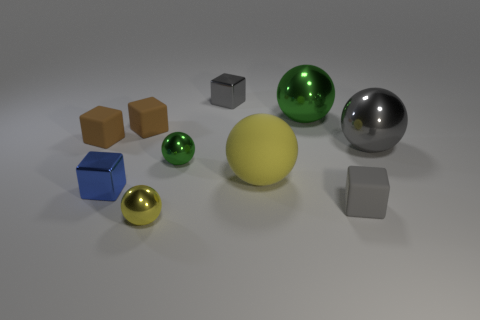Can you describe the objects at the front left side of the image? In the front left of the image, there are three objects: a small golden sphere, a medium-sized blue cube, and a larger brown cube. Each object varies in size and exhibits a distinct color and material finish. 